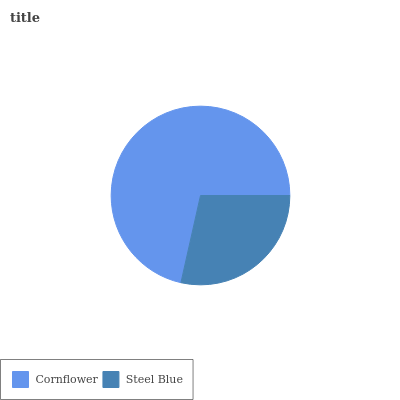Is Steel Blue the minimum?
Answer yes or no. Yes. Is Cornflower the maximum?
Answer yes or no. Yes. Is Steel Blue the maximum?
Answer yes or no. No. Is Cornflower greater than Steel Blue?
Answer yes or no. Yes. Is Steel Blue less than Cornflower?
Answer yes or no. Yes. Is Steel Blue greater than Cornflower?
Answer yes or no. No. Is Cornflower less than Steel Blue?
Answer yes or no. No. Is Cornflower the high median?
Answer yes or no. Yes. Is Steel Blue the low median?
Answer yes or no. Yes. Is Steel Blue the high median?
Answer yes or no. No. Is Cornflower the low median?
Answer yes or no. No. 